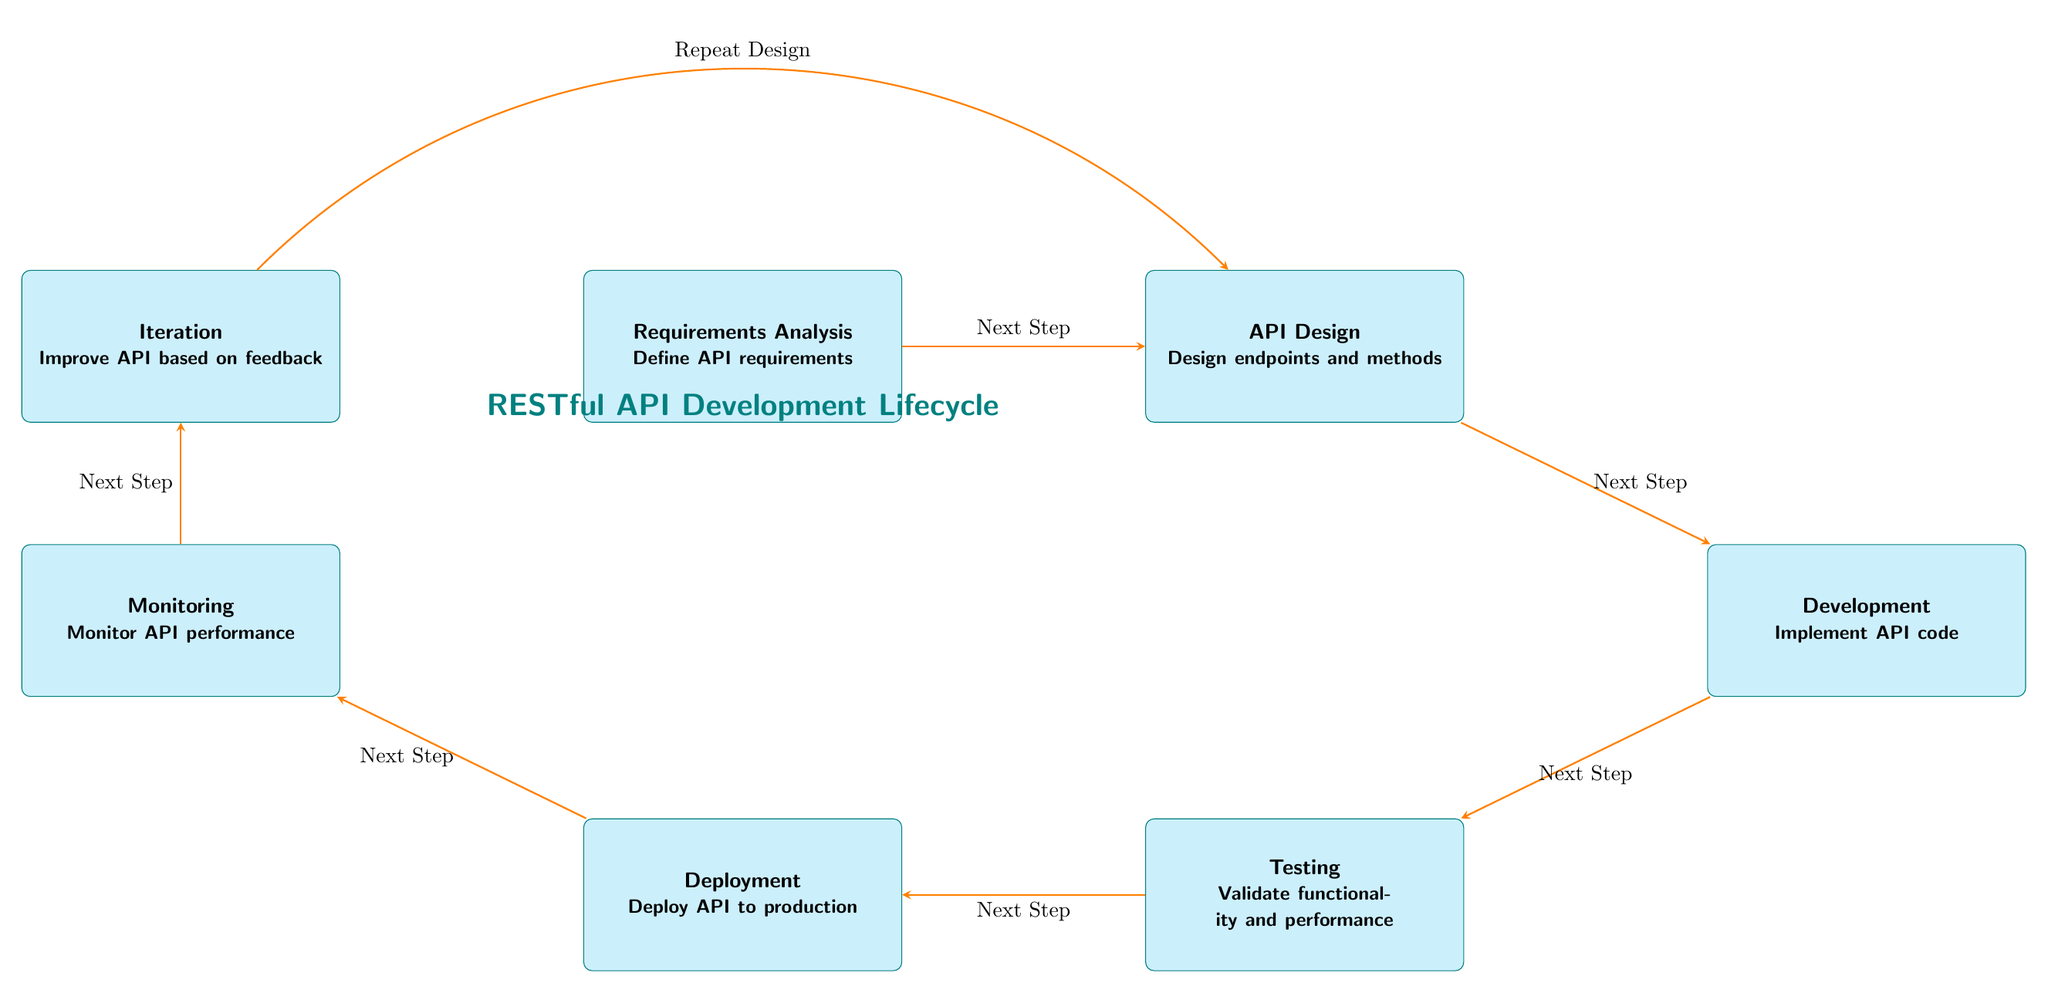What is the first step in the RESTful API Development Lifecycle? The first step is depicted at the top of the diagram, labeled "Requirements Analysis." It indicates the starting point for defining API requirements.
Answer: Requirements Analysis How many main steps are there in the RESTful API Development Lifecycle? By counting the nodes in the diagram, there are a total of 7 main steps outlined in the lifecycle of RESTful API development.
Answer: 7 What step comes directly before Deployment? The step that comes directly before Deployment, as indicated by the arrow pointing towards it, is Testing. This shows the sequence of actions leading to deployment.
Answer: Testing What action follows Monitoring? According to the flow of the diagram, the action that follows Monitoring is Iteration. This indicates a continuation to improve the API after monitoring performance.
Answer: Iteration Which two steps are connected by the "Repeat Design" arrow? The "Repeat Design" arrow connects the Iteration step back to the API Design step, indicating that feedback during iteration can lead to further design adjustments.
Answer: Iteration and API Design What is the label on the arrow from Development to Testing? The arrow from Development to Testing is labeled "Next Step," confirming that the diagram represents a linear progression from one step to the next.
Answer: Next Step Which node is positioned above Deployment? Deployment is located on the lower part of the diagram, and the node positioned directly above it is Testing. This indicates their relative locations.
Answer: Testing What does the API Design step involve? The API Design step, as described in the box, involves designing the endpoints and methods necessary for the API.
Answer: Design endpoints and methods What is the textual description for the last step in the diagram? The last step, Iteration, has the textual description "Improve API based on feedback," summarizing its purpose in the lifecycle.
Answer: Improve API based on feedback 